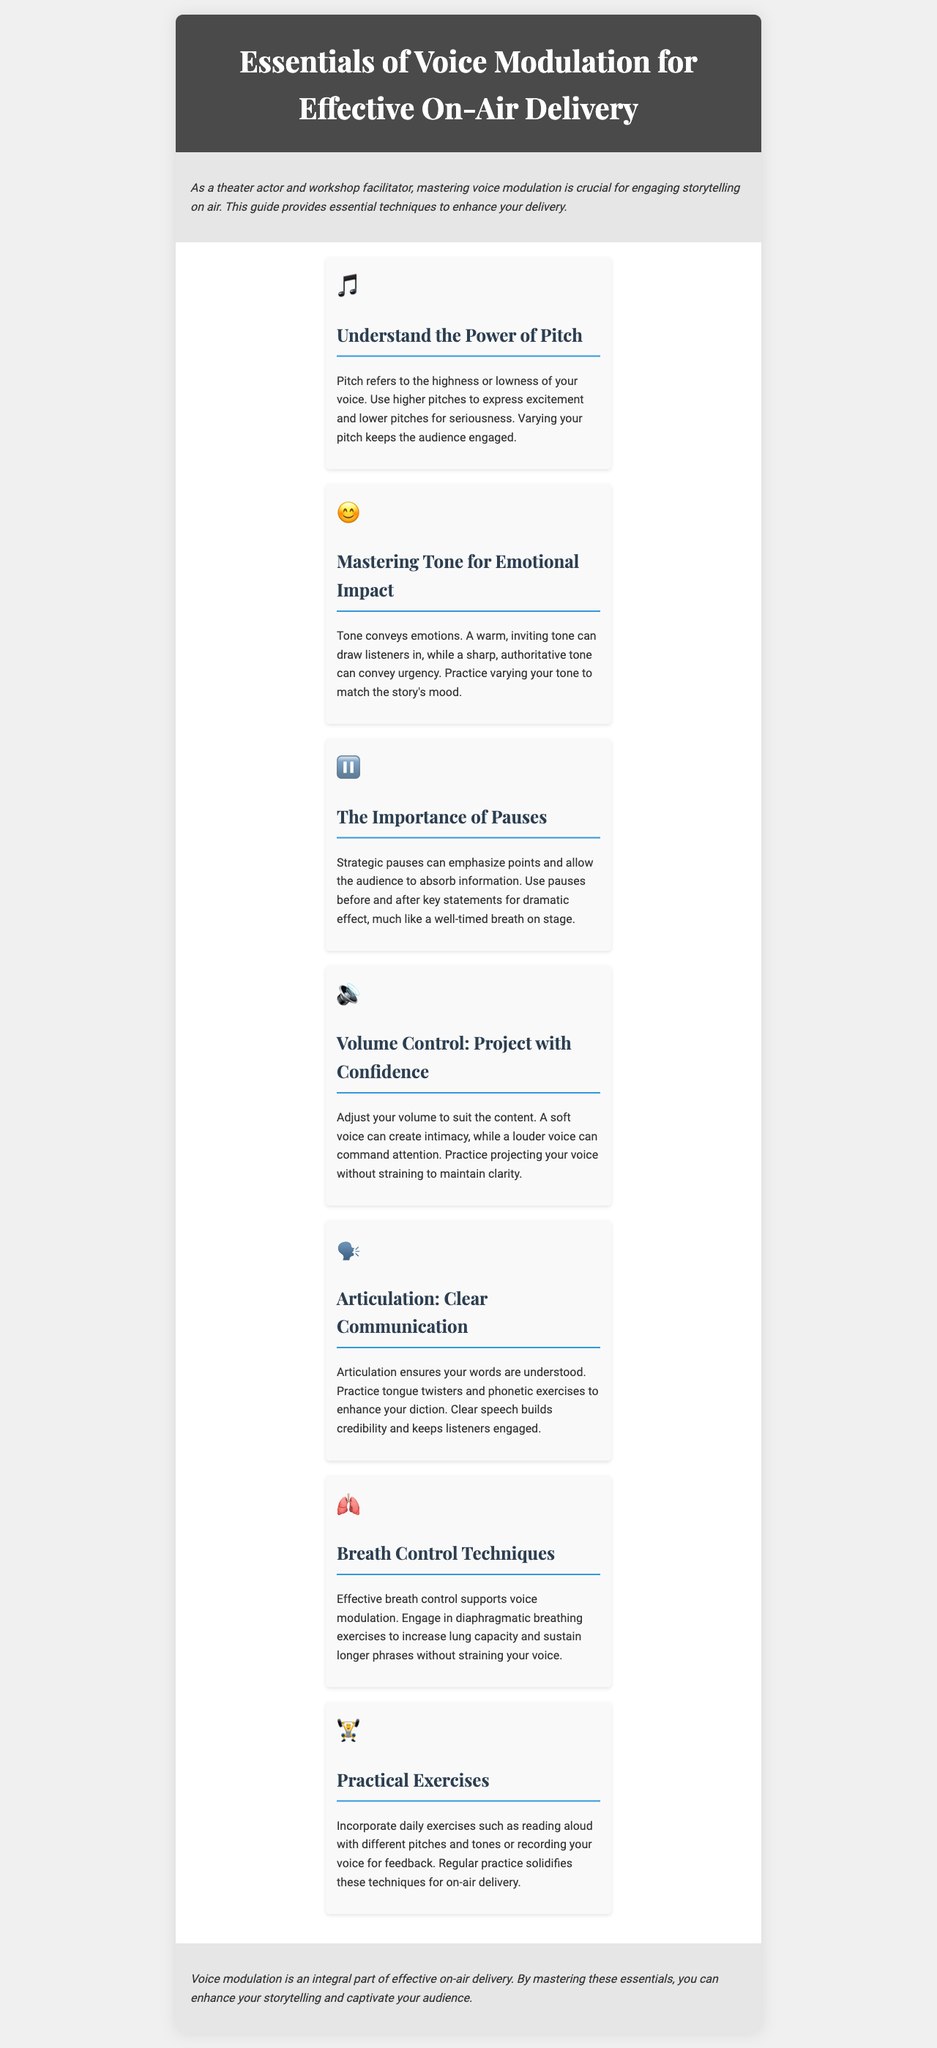What is the title of the brochure? The title is stated clearly at the top of the document in the header section.
Answer: Essentials of Voice Modulation for Effective On-Air Delivery How many main sections are there in the content? The content breaks down into different sections, categorized by techniques listed in the brochure.
Answer: Seven What emotional impact does tone convey? The document explains that tone is crucial for expressing emotions in delivery.
Answer: Emotions Which technique is emphasized for creating intimacy? The brochure specifically mentions adjusting volume for various effects in on-air delivery.
Answer: Soft voice What is the importance of strategic pauses? Strategic pauses are discussed in the context of enhancing points and allowing the audience to absorb information.
Answer: Emphasize points What daily exercises are suggested for improvement? The document provides practical advice on exercises to practice voice modulation techniques.
Answer: Reading aloud Which breathing technique is mentioned for supporting voice modulation? The brochure outlines the significance of breath control in connection to voice modulation.
Answer: Diaphragmatic breathing What is an outcome of mastering voice modulation according to the document? The brochure concludes with the benefits of effective voice modulation in storytelling.
Answer: Captivate your audience 